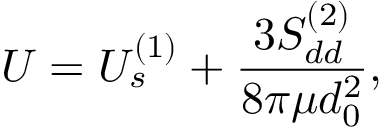<formula> <loc_0><loc_0><loc_500><loc_500>U = U _ { s } ^ { ( 1 ) } + \frac { 3 S _ { d d } ^ { ( 2 ) } } { 8 \pi \mu d _ { 0 } ^ { 2 } } ,</formula> 